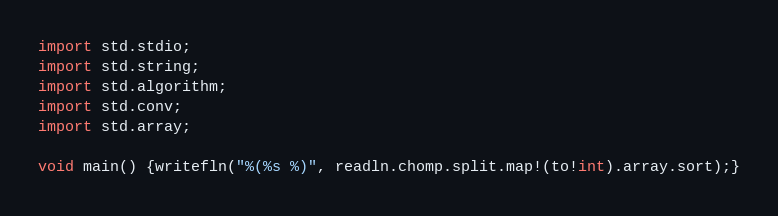<code> <loc_0><loc_0><loc_500><loc_500><_D_>import std.stdio;
import std.string;
import std.algorithm;
import std.conv;
import std.array;

void main() {writefln("%(%s %)", readln.chomp.split.map!(to!int).array.sort);}</code> 